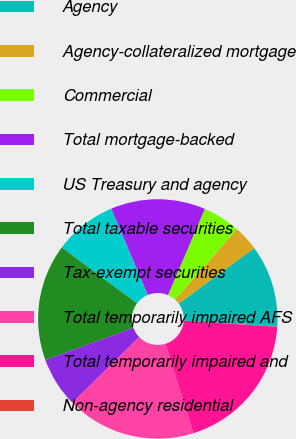Convert chart. <chart><loc_0><loc_0><loc_500><loc_500><pie_chart><fcel>Agency<fcel>Agency-collateralized mortgage<fcel>Commercial<fcel>Total mortgage-backed<fcel>US Treasury and agency<fcel>Total taxable securities<fcel>Tax-exempt securities<fcel>Total temporarily impaired AFS<fcel>Total temporarily impaired and<fcel>Non-agency residential<nl><fcel>11.12%<fcel>3.4%<fcel>5.08%<fcel>12.8%<fcel>8.45%<fcel>15.77%<fcel>6.76%<fcel>17.46%<fcel>19.14%<fcel>0.03%<nl></chart> 